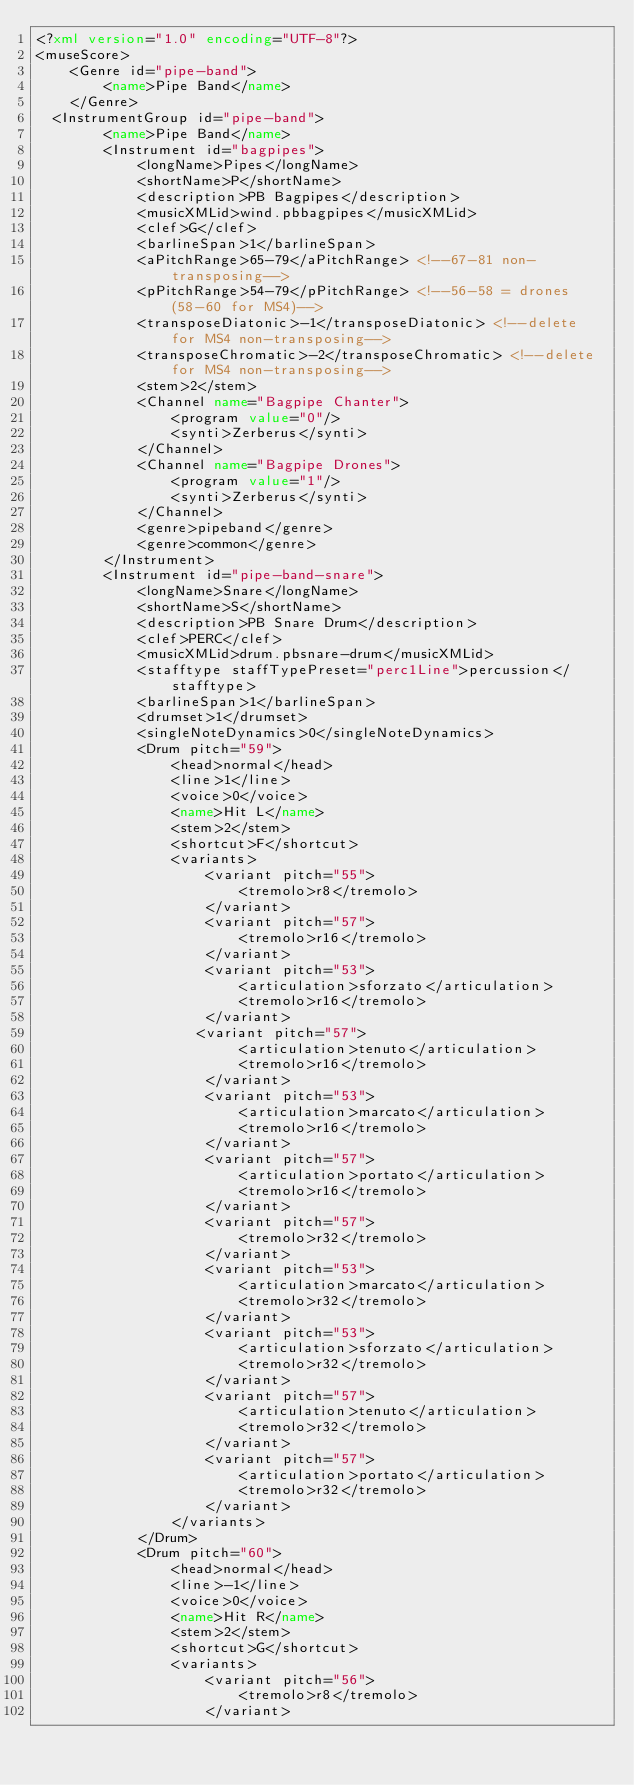Convert code to text. <code><loc_0><loc_0><loc_500><loc_500><_XML_><?xml version="1.0" encoding="UTF-8"?>
<museScore>
    <Genre id="pipe-band">
        <name>Pipe Band</name>
    </Genre>
	<InstrumentGroup id="pipe-band">
        <name>Pipe Band</name>
        <Instrument id="bagpipes">
            <longName>Pipes</longName>
            <shortName>P</shortName>
            <description>PB Bagpipes</description>
            <musicXMLid>wind.pbbagpipes</musicXMLid>
            <clef>G</clef>
            <barlineSpan>1</barlineSpan>
            <aPitchRange>65-79</aPitchRange> <!--67-81 non-transposing-->
            <pPitchRange>54-79</pPitchRange> <!--56-58 = drones (58-60 for MS4)-->
            <transposeDiatonic>-1</transposeDiatonic> <!--delete for MS4 non-transposing-->
            <transposeChromatic>-2</transposeChromatic> <!--delete for MS4 non-transposing-->			
            <stem>2</stem>
            <Channel name="Bagpipe Chanter">
                <program value="0"/>
                <synti>Zerberus</synti>
            </Channel>
            <Channel name="Bagpipe Drones">
                <program value="1"/>
                <synti>Zerberus</synti>
            </Channel>			
            <genre>pipeband</genre>
            <genre>common</genre>
        </Instrument>	
        <Instrument id="pipe-band-snare">
            <longName>Snare</longName>
            <shortName>S</shortName>
            <description>PB Snare Drum</description>
            <clef>PERC</clef>
            <musicXMLid>drum.pbsnare-drum</musicXMLid>
            <stafftype staffTypePreset="perc1Line">percussion</stafftype>
            <barlineSpan>1</barlineSpan>
            <drumset>1</drumset>
            <singleNoteDynamics>0</singleNoteDynamics>
            <Drum pitch="59">
                <head>normal</head>
                <line>1</line>
                <voice>0</voice>
                <name>Hit L</name>
                <stem>2</stem>
                <shortcut>F</shortcut>
                <variants>
                    <variant pitch="55">
                        <tremolo>r8</tremolo>
                    </variant>
                    <variant pitch="57">
                        <tremolo>r16</tremolo>
                    </variant>
                    <variant pitch="53">
                        <articulation>sforzato</articulation>
                        <tremolo>r16</tremolo>
                    </variant>
                   <variant pitch="57">
                        <articulation>tenuto</articulation>
                        <tremolo>r16</tremolo>
                    </variant>
                    <variant pitch="53">
                        <articulation>marcato</articulation>
                        <tremolo>r16</tremolo>
                    </variant>
                    <variant pitch="57">
                        <articulation>portato</articulation>
                        <tremolo>r16</tremolo>
                    </variant>
                    <variant pitch="57">
                        <tremolo>r32</tremolo>
                    </variant>
                    <variant pitch="53">
                        <articulation>marcato</articulation>
                        <tremolo>r32</tremolo>
                    </variant>
                    <variant pitch="53">
                        <articulation>sforzato</articulation>
                        <tremolo>r32</tremolo>
                    </variant>
                    <variant pitch="57">
                        <articulation>tenuto</articulation>
                        <tremolo>r32</tremolo>
                    </variant>
                    <variant pitch="57">
                        <articulation>portato</articulation>
                        <tremolo>r32</tremolo>
                    </variant>
                </variants>
            </Drum>
            <Drum pitch="60">
                <head>normal</head>
                <line>-1</line>
                <voice>0</voice>
                <name>Hit R</name>
                <stem>2</stem>
                <shortcut>G</shortcut>
                <variants>
                    <variant pitch="56">
                        <tremolo>r8</tremolo>
                    </variant></code> 